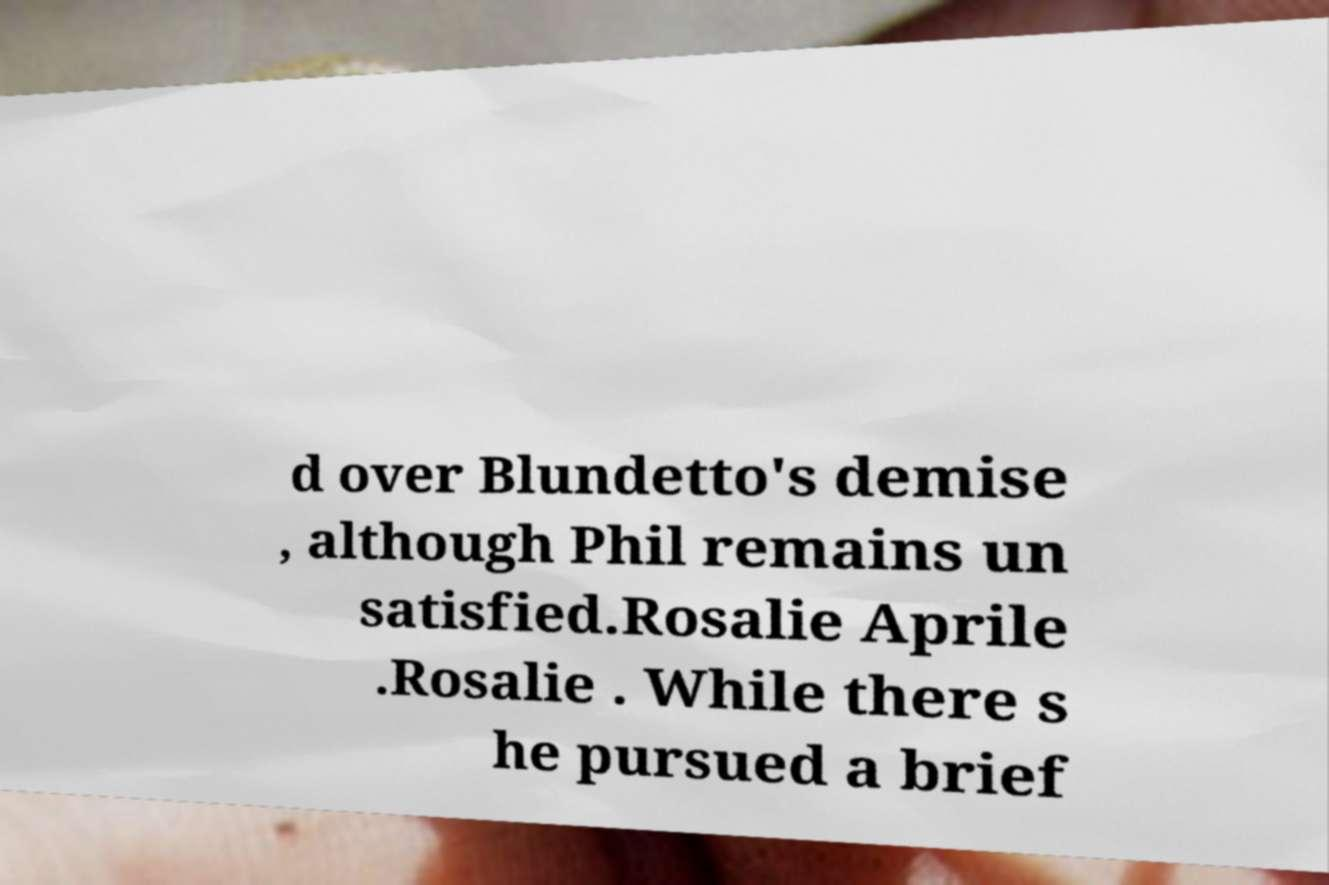Could you assist in decoding the text presented in this image and type it out clearly? d over Blundetto's demise , although Phil remains un satisfied.Rosalie Aprile .Rosalie . While there s he pursued a brief 